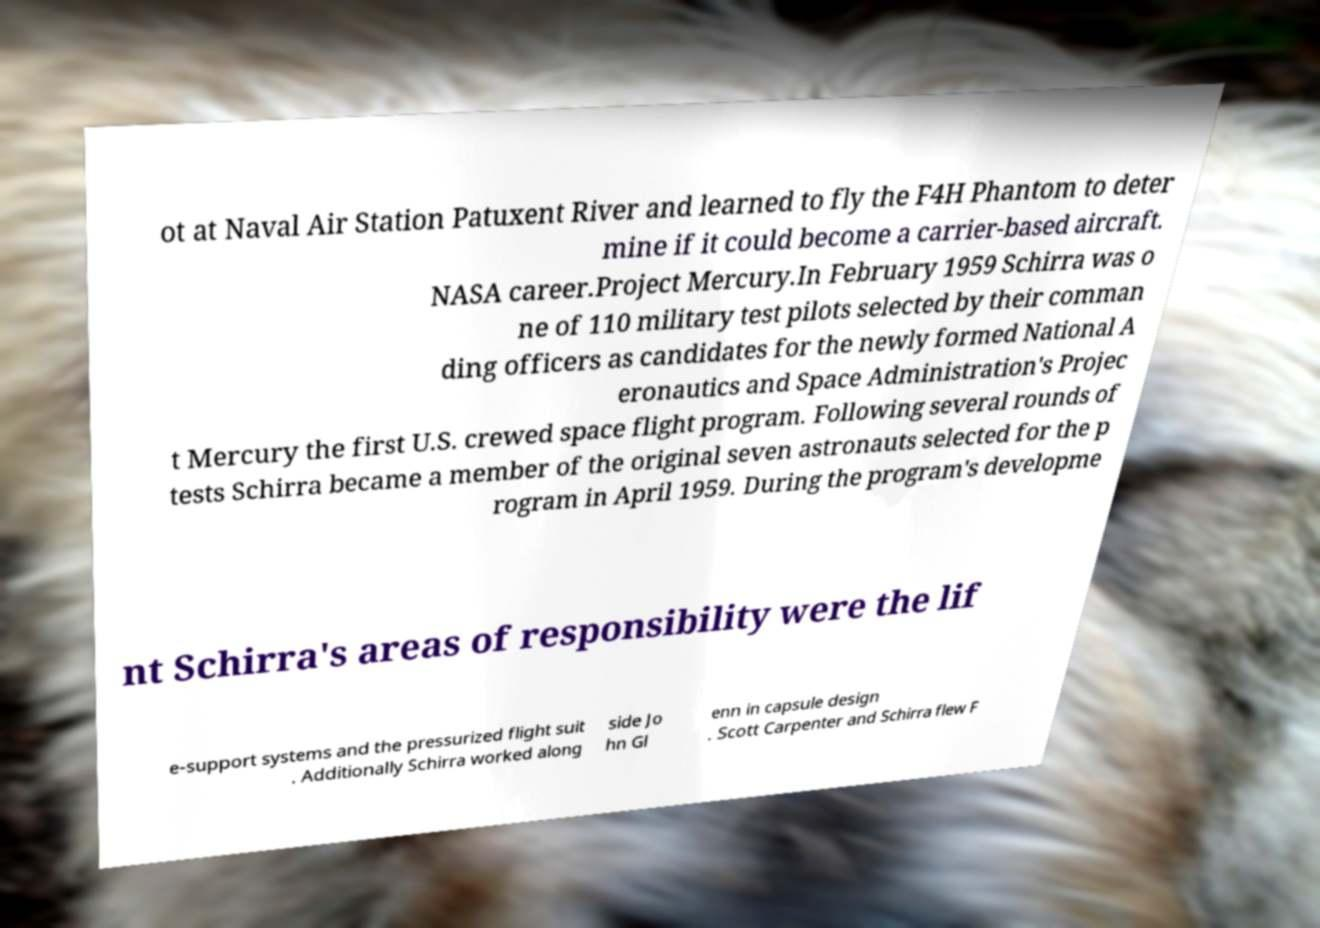I need the written content from this picture converted into text. Can you do that? ot at Naval Air Station Patuxent River and learned to fly the F4H Phantom to deter mine if it could become a carrier-based aircraft. NASA career.Project Mercury.In February 1959 Schirra was o ne of 110 military test pilots selected by their comman ding officers as candidates for the newly formed National A eronautics and Space Administration's Projec t Mercury the first U.S. crewed space flight program. Following several rounds of tests Schirra became a member of the original seven astronauts selected for the p rogram in April 1959. During the program's developme nt Schirra's areas of responsibility were the lif e-support systems and the pressurized flight suit . Additionally Schirra worked along side Jo hn Gl enn in capsule design . Scott Carpenter and Schirra flew F 